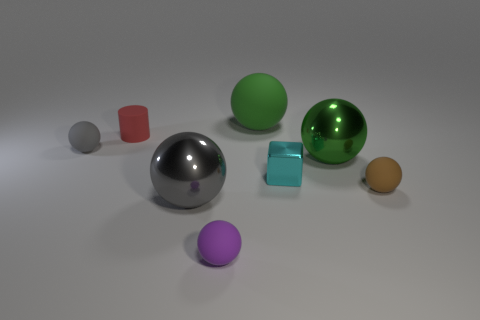Can you describe the lighting setup in this scene? The scene appears to be uniformly lit with soft shadows, suggesting diffuse lighting possibly from an overhead source. There are no harsh shadows or strong directional light, which implies that the lighting is designed to minimize contrast and mimic an overcast day or a studio with softbox lighting equipment. 